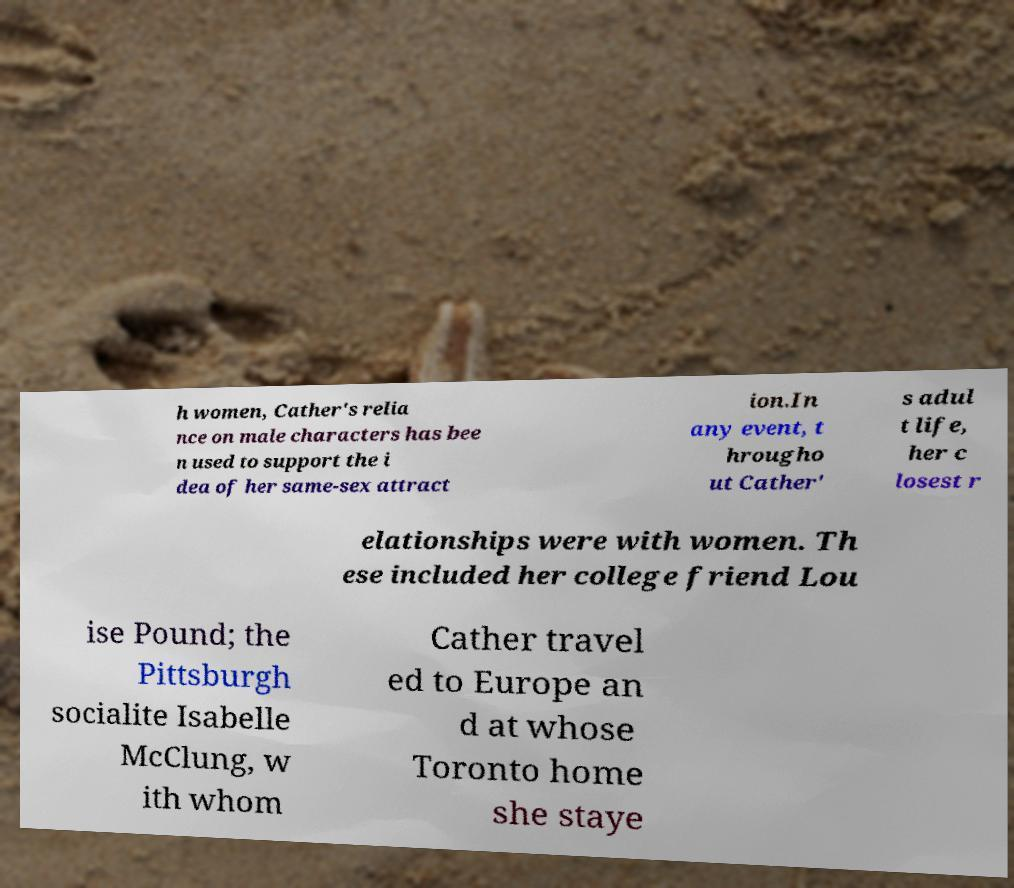Please identify and transcribe the text found in this image. h women, Cather's relia nce on male characters has bee n used to support the i dea of her same-sex attract ion.In any event, t hrougho ut Cather' s adul t life, her c losest r elationships were with women. Th ese included her college friend Lou ise Pound; the Pittsburgh socialite Isabelle McClung, w ith whom Cather travel ed to Europe an d at whose Toronto home she staye 